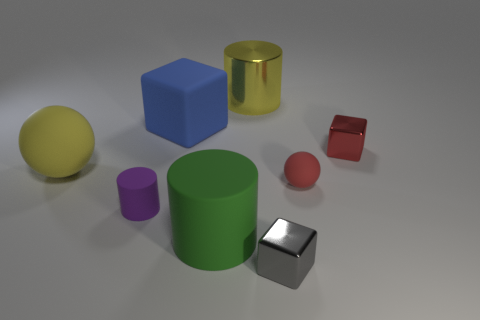Subtract all green balls. Subtract all red cylinders. How many balls are left? 2 Add 2 matte objects. How many objects exist? 10 Subtract all spheres. How many objects are left? 6 Subtract 1 red spheres. How many objects are left? 7 Subtract all tiny metallic cubes. Subtract all red balls. How many objects are left? 5 Add 1 tiny gray metal objects. How many tiny gray metal objects are left? 2 Add 1 large green cylinders. How many large green cylinders exist? 2 